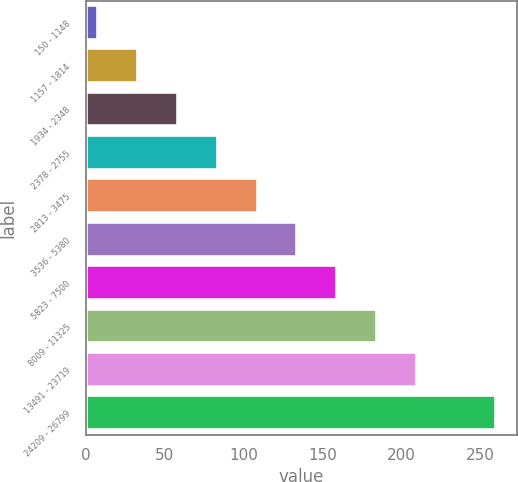Convert chart to OTSL. <chart><loc_0><loc_0><loc_500><loc_500><bar_chart><fcel>150 - 1148<fcel>1157 - 1814<fcel>1934 - 2348<fcel>2378 - 2755<fcel>2813 - 3475<fcel>3536 - 5380<fcel>5823 - 7500<fcel>8009 - 11325<fcel>13491 - 23719<fcel>24209 - 26799<nl><fcel>8.08<fcel>33.27<fcel>58.46<fcel>83.65<fcel>108.84<fcel>134.03<fcel>159.22<fcel>184.41<fcel>209.6<fcel>259.98<nl></chart> 